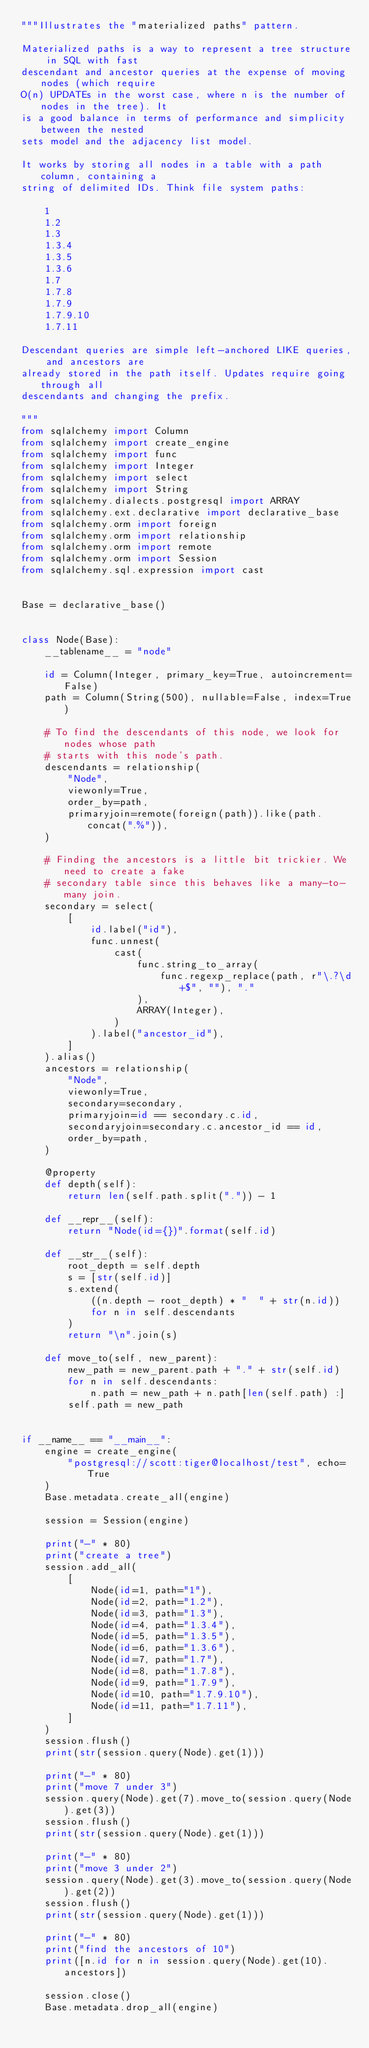Convert code to text. <code><loc_0><loc_0><loc_500><loc_500><_Python_>"""Illustrates the "materialized paths" pattern.

Materialized paths is a way to represent a tree structure in SQL with fast
descendant and ancestor queries at the expense of moving nodes (which require
O(n) UPDATEs in the worst case, where n is the number of nodes in the tree). It
is a good balance in terms of performance and simplicity between the nested
sets model and the adjacency list model.

It works by storing all nodes in a table with a path column, containing a
string of delimited IDs. Think file system paths:

    1
    1.2
    1.3
    1.3.4
    1.3.5
    1.3.6
    1.7
    1.7.8
    1.7.9
    1.7.9.10
    1.7.11

Descendant queries are simple left-anchored LIKE queries, and ancestors are
already stored in the path itself. Updates require going through all
descendants and changing the prefix.

"""
from sqlalchemy import Column
from sqlalchemy import create_engine
from sqlalchemy import func
from sqlalchemy import Integer
from sqlalchemy import select
from sqlalchemy import String
from sqlalchemy.dialects.postgresql import ARRAY
from sqlalchemy.ext.declarative import declarative_base
from sqlalchemy.orm import foreign
from sqlalchemy.orm import relationship
from sqlalchemy.orm import remote
from sqlalchemy.orm import Session
from sqlalchemy.sql.expression import cast


Base = declarative_base()


class Node(Base):
    __tablename__ = "node"

    id = Column(Integer, primary_key=True, autoincrement=False)
    path = Column(String(500), nullable=False, index=True)

    # To find the descendants of this node, we look for nodes whose path
    # starts with this node's path.
    descendants = relationship(
        "Node",
        viewonly=True,
        order_by=path,
        primaryjoin=remote(foreign(path)).like(path.concat(".%")),
    )

    # Finding the ancestors is a little bit trickier. We need to create a fake
    # secondary table since this behaves like a many-to-many join.
    secondary = select(
        [
            id.label("id"),
            func.unnest(
                cast(
                    func.string_to_array(
                        func.regexp_replace(path, r"\.?\d+$", ""), "."
                    ),
                    ARRAY(Integer),
                )
            ).label("ancestor_id"),
        ]
    ).alias()
    ancestors = relationship(
        "Node",
        viewonly=True,
        secondary=secondary,
        primaryjoin=id == secondary.c.id,
        secondaryjoin=secondary.c.ancestor_id == id,
        order_by=path,
    )

    @property
    def depth(self):
        return len(self.path.split(".")) - 1

    def __repr__(self):
        return "Node(id={})".format(self.id)

    def __str__(self):
        root_depth = self.depth
        s = [str(self.id)]
        s.extend(
            ((n.depth - root_depth) * "  " + str(n.id))
            for n in self.descendants
        )
        return "\n".join(s)

    def move_to(self, new_parent):
        new_path = new_parent.path + "." + str(self.id)
        for n in self.descendants:
            n.path = new_path + n.path[len(self.path) :]
        self.path = new_path


if __name__ == "__main__":
    engine = create_engine(
        "postgresql://scott:tiger@localhost/test", echo=True
    )
    Base.metadata.create_all(engine)

    session = Session(engine)

    print("-" * 80)
    print("create a tree")
    session.add_all(
        [
            Node(id=1, path="1"),
            Node(id=2, path="1.2"),
            Node(id=3, path="1.3"),
            Node(id=4, path="1.3.4"),
            Node(id=5, path="1.3.5"),
            Node(id=6, path="1.3.6"),
            Node(id=7, path="1.7"),
            Node(id=8, path="1.7.8"),
            Node(id=9, path="1.7.9"),
            Node(id=10, path="1.7.9.10"),
            Node(id=11, path="1.7.11"),
        ]
    )
    session.flush()
    print(str(session.query(Node).get(1)))

    print("-" * 80)
    print("move 7 under 3")
    session.query(Node).get(7).move_to(session.query(Node).get(3))
    session.flush()
    print(str(session.query(Node).get(1)))

    print("-" * 80)
    print("move 3 under 2")
    session.query(Node).get(3).move_to(session.query(Node).get(2))
    session.flush()
    print(str(session.query(Node).get(1)))

    print("-" * 80)
    print("find the ancestors of 10")
    print([n.id for n in session.query(Node).get(10).ancestors])

    session.close()
    Base.metadata.drop_all(engine)
</code> 